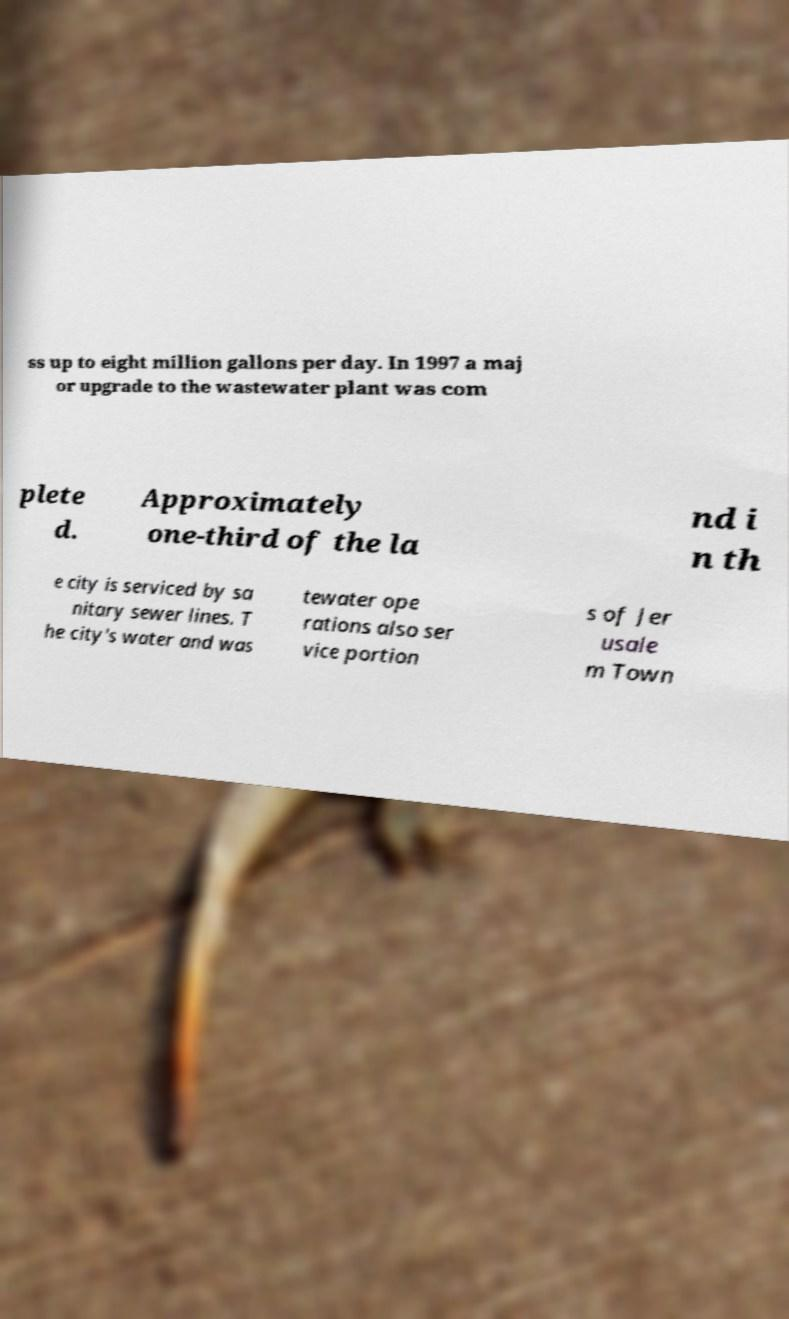For documentation purposes, I need the text within this image transcribed. Could you provide that? ss up to eight million gallons per day. In 1997 a maj or upgrade to the wastewater plant was com plete d. Approximately one-third of the la nd i n th e city is serviced by sa nitary sewer lines. T he city's water and was tewater ope rations also ser vice portion s of Jer usale m Town 